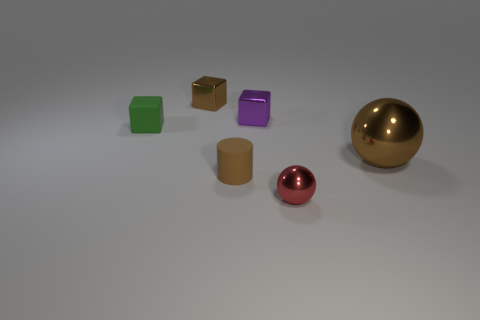What number of cubes are either tiny things or tiny red metallic things?
Ensure brevity in your answer.  3. Are there any tiny red matte blocks?
Provide a succinct answer. No. Are there any other things that are the same shape as the red thing?
Your answer should be compact. Yes. Is the color of the large shiny ball the same as the tiny ball?
Ensure brevity in your answer.  No. What number of things are either small objects that are on the right side of the brown matte object or matte cubes?
Your answer should be compact. 3. There is a brown metal thing behind the sphere that is behind the red ball; how many blocks are in front of it?
Give a very brief answer. 2. Are there any other things that have the same size as the brown cylinder?
Keep it short and to the point. Yes. There is a metal thing in front of the big object behind the red metallic ball on the right side of the purple thing; what shape is it?
Give a very brief answer. Sphere. How many other things are there of the same color as the big metallic ball?
Make the answer very short. 2. There is a rubber object right of the metallic cube that is to the left of the purple metallic block; what shape is it?
Provide a short and direct response. Cylinder. 